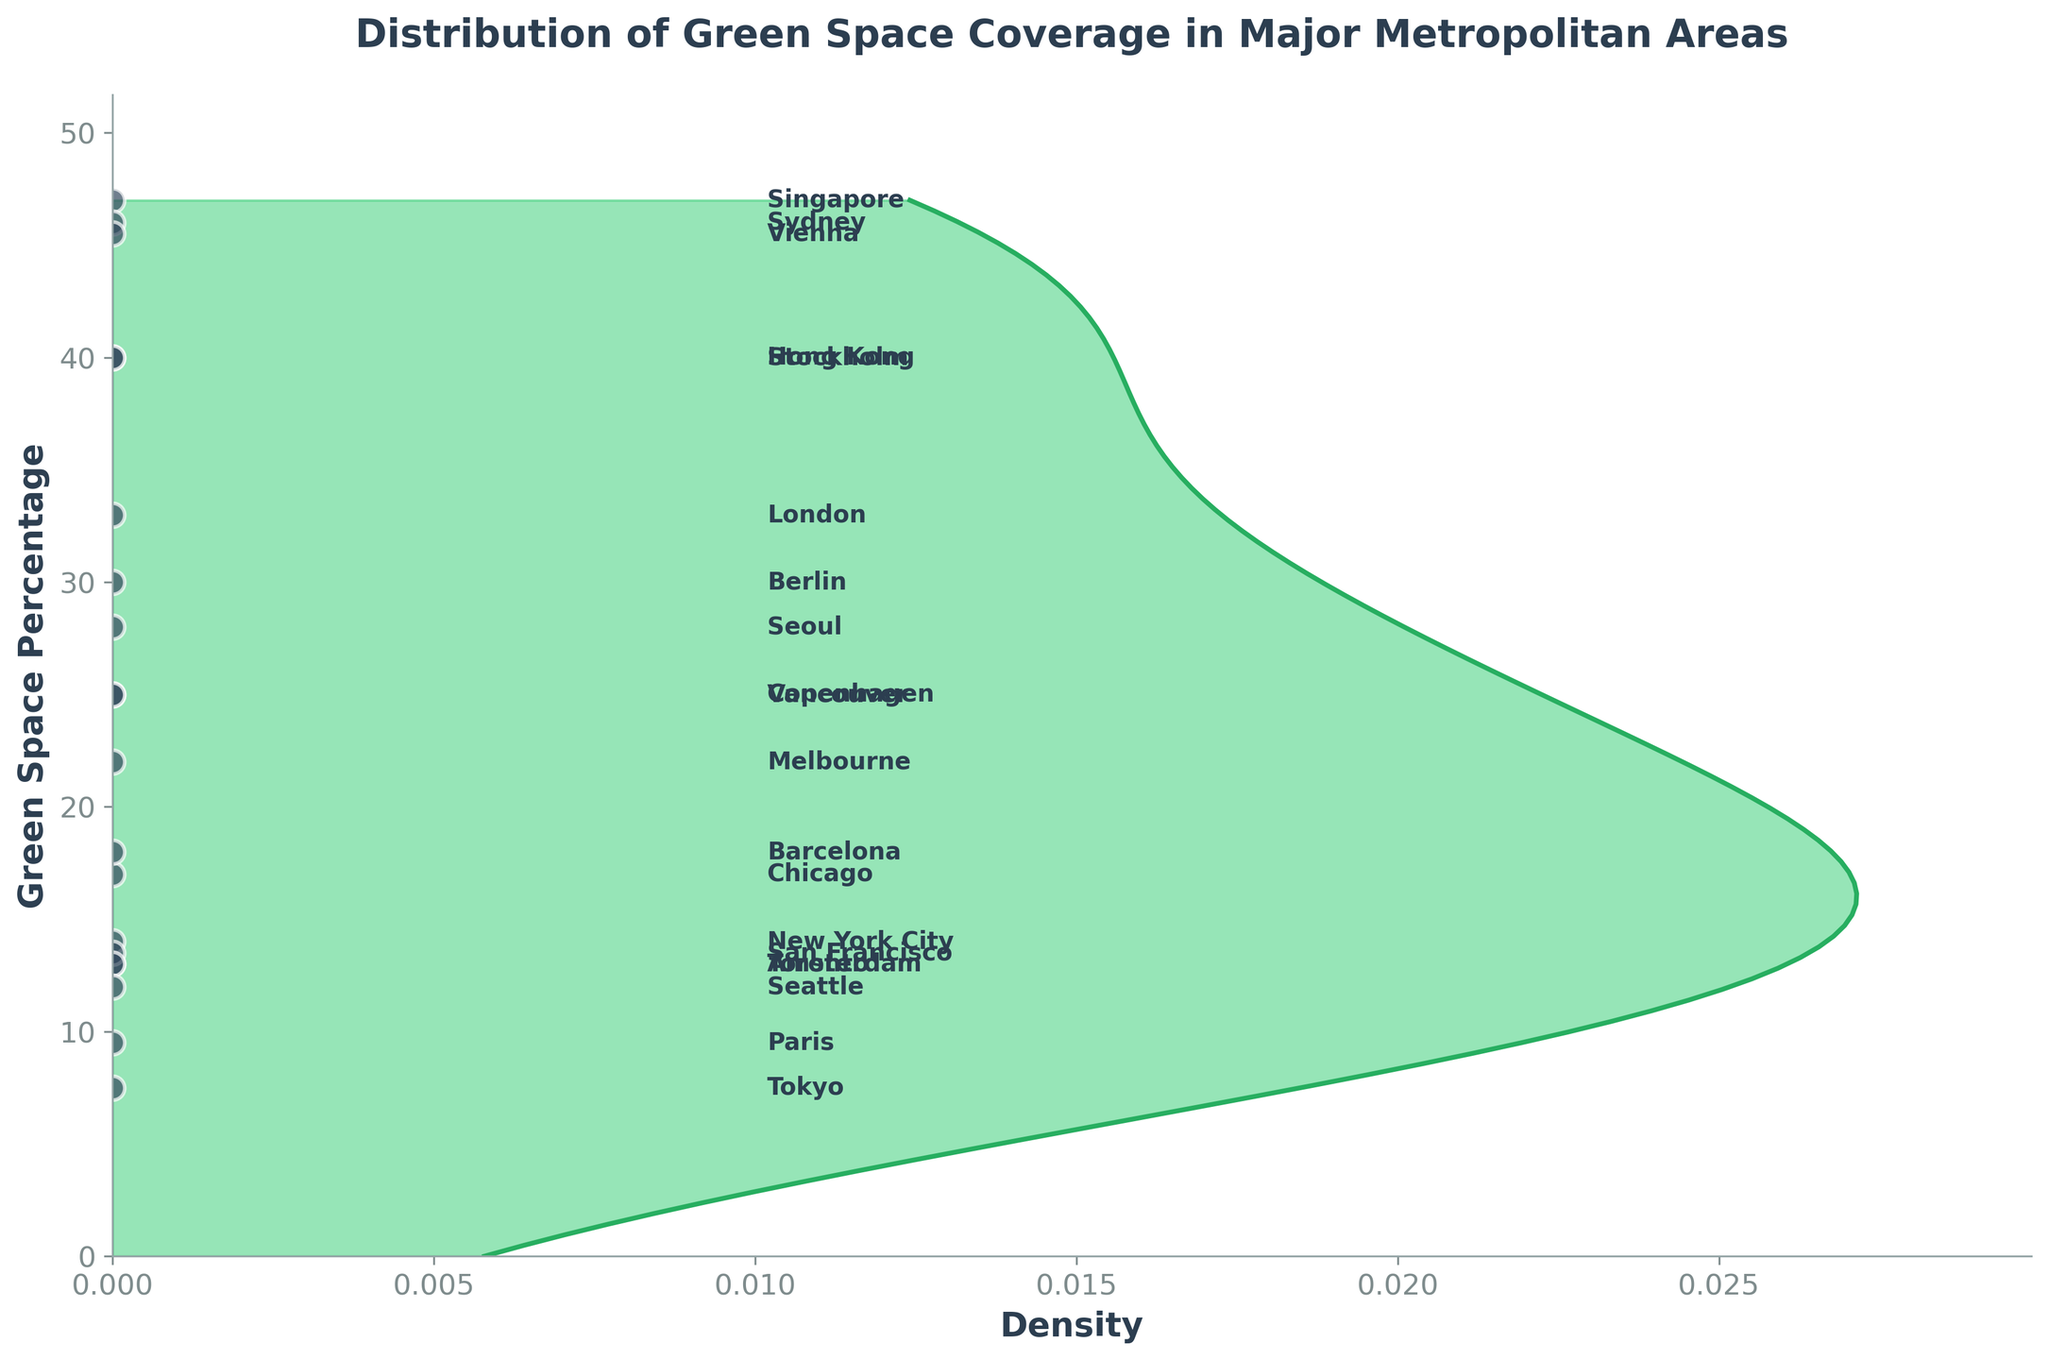What is the title of the plot? The title is positioned above the plot and reads "Distribution of Green Space Coverage in Major Metropolitan Areas."
Answer: Distribution of Green Space Coverage in Major Metropolitan Areas Which city has the highest percentage of green space? By observing the labeled data points along the vertical axis, Singapore has the highest percentage, indicated as 47%.
Answer: Singapore What is the green space percentage for New York City? The green space percentage of each city is labeled next to each point, New York City's green space is 14%.
Answer: 14% Which cities have a green space coverage percentage higher than 40%? Examining the labeled data points, Singapore (47%), Stockholm (40%), Vienna (45.5%), and Hong Kong (40%) have green space percentages higher than 40%.
Answer: Singapore, Stockholm, Vienna, Hong Kong Count how many cities have more than 20% green space coverage. By checking each labeled point, we find 8 cities with green space percentages higher than 20%: London, Singapore, Berlin, Sydney, Vancouver, Melbourne, Copenhagen, Stockholm, and Vienna.
Answer: 8 Which city has the lowest percentage of green space, and what is the percentage? By observing the vertical position of each labeled point, Tokyo is the lowest with a green space percentage of 7.5%.
Answer: Tokyo, 7.5% What is the mean green space percentage among all cities? First, sum all the percentages: 14 + 33 + 7.5 + 47 + 9.5 + 30 + 46 + 25 + 13 + 28 + 17 + 18 + 13.5 + 13 + 22 + 25 + 40 + 45.5 + 40 + 12 = 508, then divide by the number of cities (20). The mean percentage is 508 / 20 = 25.4%.
Answer: 25.4% Are there more cities with green space coverage below or above the mean value? The mean is 25.4%. Counting cities below and above this value: Below: 11 cities (New York City, Tokyo, Paris, Amsterdam, Seoul, Chicago, Barcelona, San Francisco, Toronto, Seattle). Above: 9 cities (London, Singapore, Berlin, Sydney, Vancouver, Melbourne, Copenhagen, Stockholm, Vienna, Hong Kong).
Answer: Below What is the approximate density of locations with a green space percentage of 30? The density curve visually shows that at 30, the density appears to be higher than many other areas. Looking closely, the density value seems to peak around that area, giving an approximate density slightly lower than the peak density.
Answer: High density, slightly lower than peak density How is the distribution of green space coverage in major metropolitan areas skewed? The plot’s shape shows a longer tail on the left, indicating that it is skewed to the left or negatively skewed. Most cities have green space coverage around or below the mean value, with fewer cities having high values.
Answer: Left-skewed or negatively skewed 